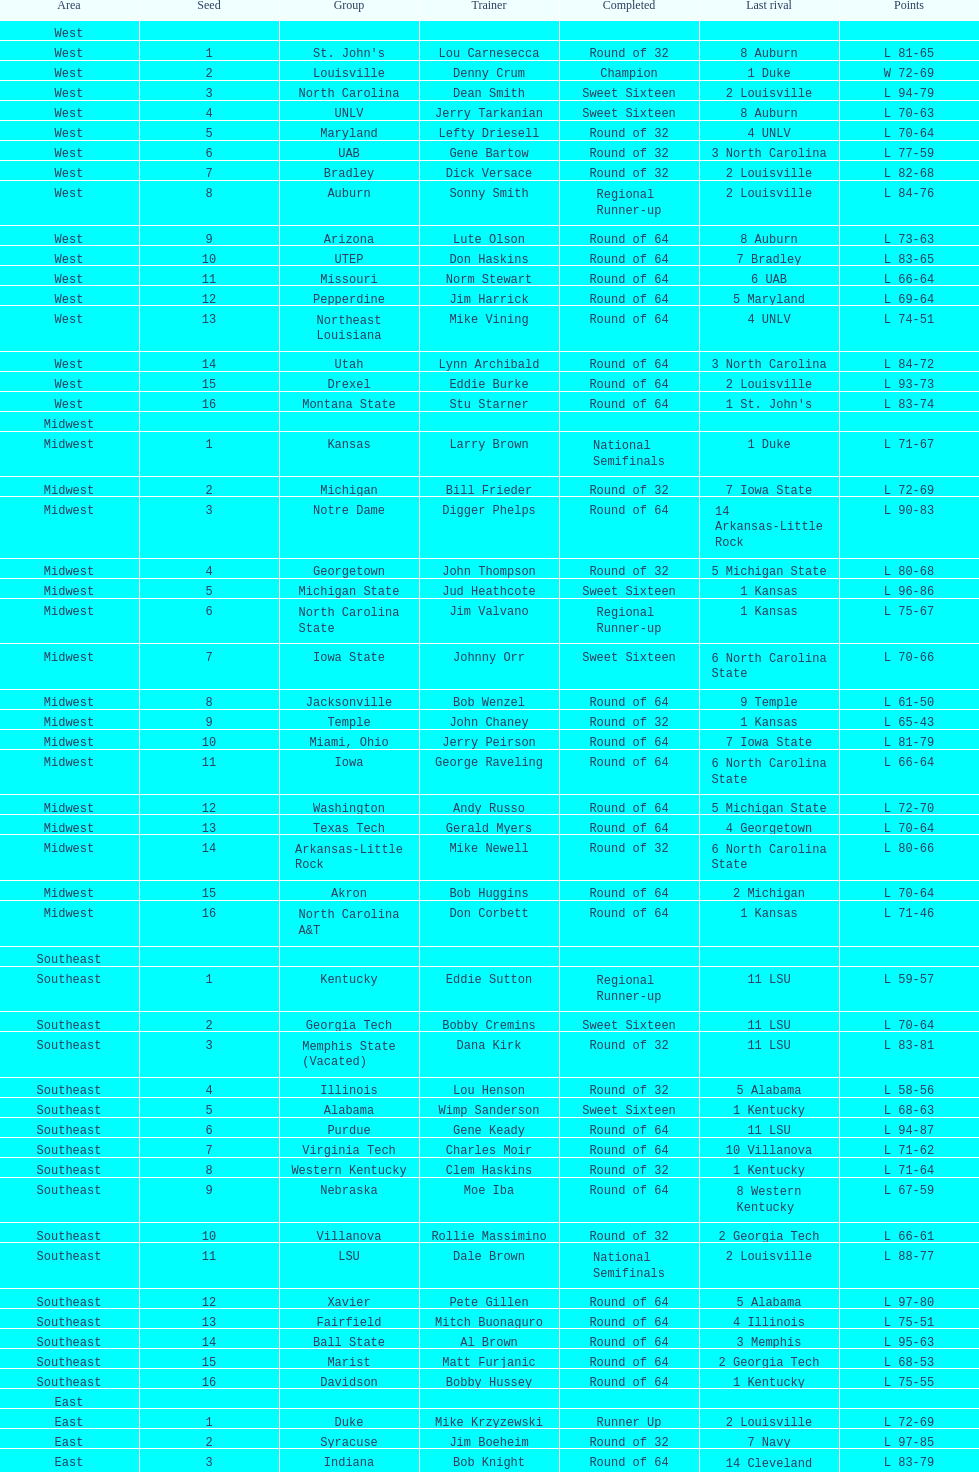Can you parse all the data within this table? {'header': ['Area', 'Seed', 'Group', 'Trainer', 'Completed', 'Last rival', 'Points'], 'rows': [['West', '', '', '', '', '', ''], ['West', '1', "St. John's", 'Lou Carnesecca', 'Round of 32', '8 Auburn', 'L 81-65'], ['West', '2', 'Louisville', 'Denny Crum', 'Champion', '1 Duke', 'W 72-69'], ['West', '3', 'North Carolina', 'Dean Smith', 'Sweet Sixteen', '2 Louisville', 'L 94-79'], ['West', '4', 'UNLV', 'Jerry Tarkanian', 'Sweet Sixteen', '8 Auburn', 'L 70-63'], ['West', '5', 'Maryland', 'Lefty Driesell', 'Round of 32', '4 UNLV', 'L 70-64'], ['West', '6', 'UAB', 'Gene Bartow', 'Round of 32', '3 North Carolina', 'L 77-59'], ['West', '7', 'Bradley', 'Dick Versace', 'Round of 32', '2 Louisville', 'L 82-68'], ['West', '8', 'Auburn', 'Sonny Smith', 'Regional Runner-up', '2 Louisville', 'L 84-76'], ['West', '9', 'Arizona', 'Lute Olson', 'Round of 64', '8 Auburn', 'L 73-63'], ['West', '10', 'UTEP', 'Don Haskins', 'Round of 64', '7 Bradley', 'L 83-65'], ['West', '11', 'Missouri', 'Norm Stewart', 'Round of 64', '6 UAB', 'L 66-64'], ['West', '12', 'Pepperdine', 'Jim Harrick', 'Round of 64', '5 Maryland', 'L 69-64'], ['West', '13', 'Northeast Louisiana', 'Mike Vining', 'Round of 64', '4 UNLV', 'L 74-51'], ['West', '14', 'Utah', 'Lynn Archibald', 'Round of 64', '3 North Carolina', 'L 84-72'], ['West', '15', 'Drexel', 'Eddie Burke', 'Round of 64', '2 Louisville', 'L 93-73'], ['West', '16', 'Montana State', 'Stu Starner', 'Round of 64', "1 St. John's", 'L 83-74'], ['Midwest', '', '', '', '', '', ''], ['Midwest', '1', 'Kansas', 'Larry Brown', 'National Semifinals', '1 Duke', 'L 71-67'], ['Midwest', '2', 'Michigan', 'Bill Frieder', 'Round of 32', '7 Iowa State', 'L 72-69'], ['Midwest', '3', 'Notre Dame', 'Digger Phelps', 'Round of 64', '14 Arkansas-Little Rock', 'L 90-83'], ['Midwest', '4', 'Georgetown', 'John Thompson', 'Round of 32', '5 Michigan State', 'L 80-68'], ['Midwest', '5', 'Michigan State', 'Jud Heathcote', 'Sweet Sixteen', '1 Kansas', 'L 96-86'], ['Midwest', '6', 'North Carolina State', 'Jim Valvano', 'Regional Runner-up', '1 Kansas', 'L 75-67'], ['Midwest', '7', 'Iowa State', 'Johnny Orr', 'Sweet Sixteen', '6 North Carolina State', 'L 70-66'], ['Midwest', '8', 'Jacksonville', 'Bob Wenzel', 'Round of 64', '9 Temple', 'L 61-50'], ['Midwest', '9', 'Temple', 'John Chaney', 'Round of 32', '1 Kansas', 'L 65-43'], ['Midwest', '10', 'Miami, Ohio', 'Jerry Peirson', 'Round of 64', '7 Iowa State', 'L 81-79'], ['Midwest', '11', 'Iowa', 'George Raveling', 'Round of 64', '6 North Carolina State', 'L 66-64'], ['Midwest', '12', 'Washington', 'Andy Russo', 'Round of 64', '5 Michigan State', 'L 72-70'], ['Midwest', '13', 'Texas Tech', 'Gerald Myers', 'Round of 64', '4 Georgetown', 'L 70-64'], ['Midwest', '14', 'Arkansas-Little Rock', 'Mike Newell', 'Round of 32', '6 North Carolina State', 'L 80-66'], ['Midwest', '15', 'Akron', 'Bob Huggins', 'Round of 64', '2 Michigan', 'L 70-64'], ['Midwest', '16', 'North Carolina A&T', 'Don Corbett', 'Round of 64', '1 Kansas', 'L 71-46'], ['Southeast', '', '', '', '', '', ''], ['Southeast', '1', 'Kentucky', 'Eddie Sutton', 'Regional Runner-up', '11 LSU', 'L 59-57'], ['Southeast', '2', 'Georgia Tech', 'Bobby Cremins', 'Sweet Sixteen', '11 LSU', 'L 70-64'], ['Southeast', '3', 'Memphis State (Vacated)', 'Dana Kirk', 'Round of 32', '11 LSU', 'L 83-81'], ['Southeast', '4', 'Illinois', 'Lou Henson', 'Round of 32', '5 Alabama', 'L 58-56'], ['Southeast', '5', 'Alabama', 'Wimp Sanderson', 'Sweet Sixteen', '1 Kentucky', 'L 68-63'], ['Southeast', '6', 'Purdue', 'Gene Keady', 'Round of 64', '11 LSU', 'L 94-87'], ['Southeast', '7', 'Virginia Tech', 'Charles Moir', 'Round of 64', '10 Villanova', 'L 71-62'], ['Southeast', '8', 'Western Kentucky', 'Clem Haskins', 'Round of 32', '1 Kentucky', 'L 71-64'], ['Southeast', '9', 'Nebraska', 'Moe Iba', 'Round of 64', '8 Western Kentucky', 'L 67-59'], ['Southeast', '10', 'Villanova', 'Rollie Massimino', 'Round of 32', '2 Georgia Tech', 'L 66-61'], ['Southeast', '11', 'LSU', 'Dale Brown', 'National Semifinals', '2 Louisville', 'L 88-77'], ['Southeast', '12', 'Xavier', 'Pete Gillen', 'Round of 64', '5 Alabama', 'L 97-80'], ['Southeast', '13', 'Fairfield', 'Mitch Buonaguro', 'Round of 64', '4 Illinois', 'L 75-51'], ['Southeast', '14', 'Ball State', 'Al Brown', 'Round of 64', '3 Memphis', 'L 95-63'], ['Southeast', '15', 'Marist', 'Matt Furjanic', 'Round of 64', '2 Georgia Tech', 'L 68-53'], ['Southeast', '16', 'Davidson', 'Bobby Hussey', 'Round of 64', '1 Kentucky', 'L 75-55'], ['East', '', '', '', '', '', ''], ['East', '1', 'Duke', 'Mike Krzyzewski', 'Runner Up', '2 Louisville', 'L 72-69'], ['East', '2', 'Syracuse', 'Jim Boeheim', 'Round of 32', '7 Navy', 'L 97-85'], ['East', '3', 'Indiana', 'Bob Knight', 'Round of 64', '14 Cleveland State', 'L 83-79'], ['East', '4', 'Oklahoma', 'Billy Tubbs', 'Round of 32', '12 DePaul', 'L 74-69'], ['East', '5', 'Virginia', 'Terry Holland', 'Round of 64', '12 DePaul', 'L 72-68'], ['East', '6', "Saint Joseph's", 'Jim Boyle', 'Round of 32', '14 Cleveland State', 'L 75-69'], ['East', '7', 'Navy', 'Paul Evans', 'Regional Runner-up', '1 Duke', 'L 71-50'], ['East', '8', 'Old Dominion', 'Tom Young', 'Round of 32', '1 Duke', 'L 89-61'], ['East', '9', 'West Virginia', 'Gale Catlett', 'Round of 64', '8 Old Dominion', 'L 72-64'], ['East', '10', 'Tulsa', 'J. D. Barnett', 'Round of 64', '7 Navy', 'L 87-68'], ['East', '11', 'Richmond', 'Dick Tarrant', 'Round of 64', "6 Saint Joseph's", 'L 60-59'], ['East', '12', 'DePaul', 'Joey Meyer', 'Sweet Sixteen', '1 Duke', 'L 74-67'], ['East', '13', 'Northeastern', 'Jim Calhoun', 'Round of 64', '4 Oklahoma', 'L 80-74'], ['East', '14', 'Cleveland State', 'Kevin Mackey', 'Sweet Sixteen', '7 Navy', 'L 71-70'], ['East', '15', 'Brown', 'Mike Cingiser', 'Round of 64', '2 Syracuse', 'L 101-52'], ['East', '16', 'Mississippi Valley State', 'Lafayette Stribling', 'Round of 64', '1 Duke', 'L 85-78']]} What team finished at the top of all else and was finished as champions? Louisville. 